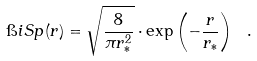Convert formula to latex. <formula><loc_0><loc_0><loc_500><loc_500>\i i S p ( r ) = \sqrt { \frac { 8 } { \pi r _ { * } ^ { 2 } } } \cdot \exp \left ( - \frac { r } { r _ { * } } \right ) \ .</formula> 